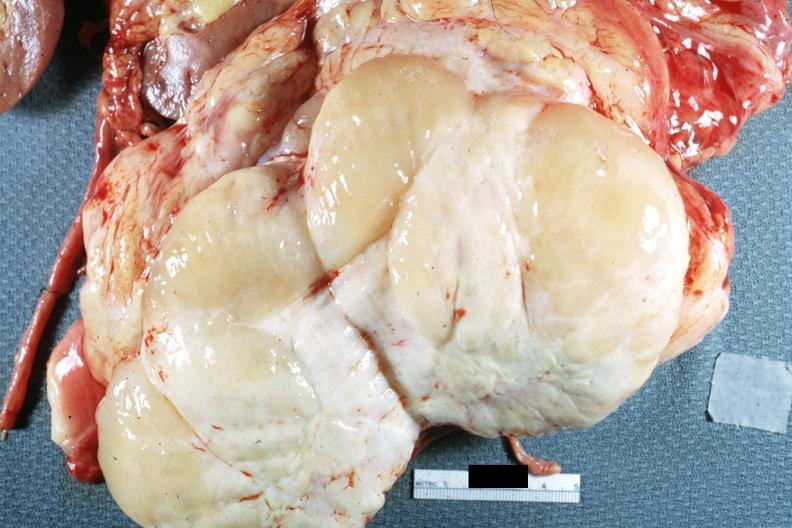how is nodular tumor cut surface natural color yellow and white typical sarcoma?
Answer the question using a single word or phrase. Gross 